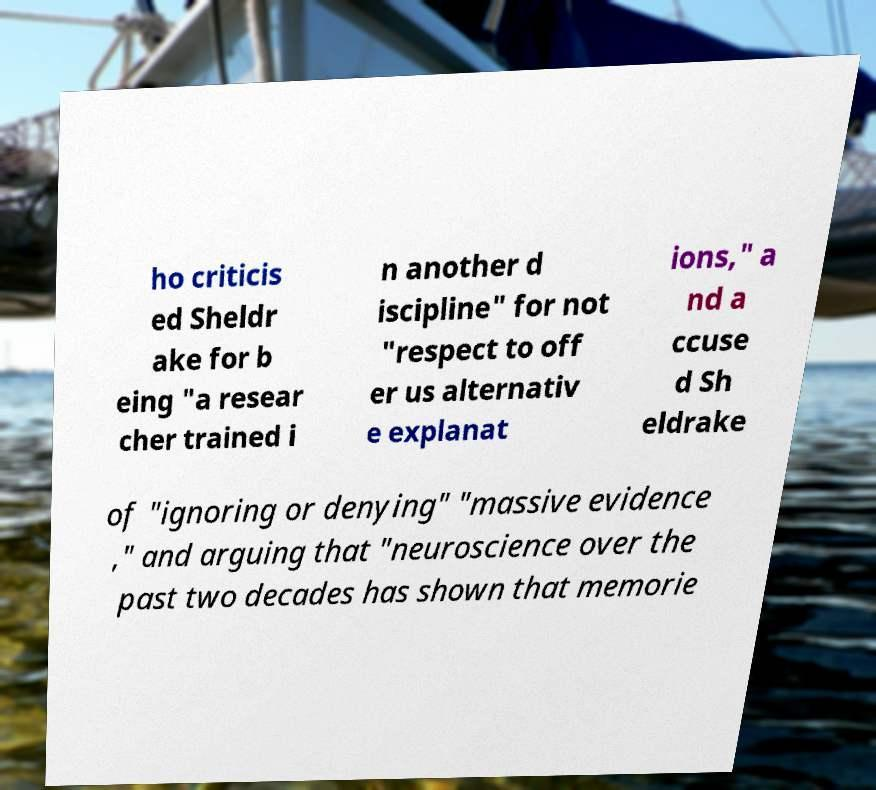Please read and relay the text visible in this image. What does it say? ho criticis ed Sheldr ake for b eing "a resear cher trained i n another d iscipline" for not "respect to off er us alternativ e explanat ions," a nd a ccuse d Sh eldrake of "ignoring or denying" "massive evidence ," and arguing that "neuroscience over the past two decades has shown that memorie 